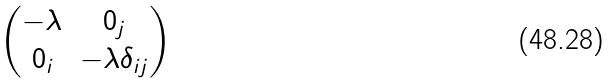Convert formula to latex. <formula><loc_0><loc_0><loc_500><loc_500>\begin{pmatrix} - \lambda & 0 _ { j } \\ 0 _ { i } & - \lambda \delta _ { i j } \end{pmatrix}</formula> 